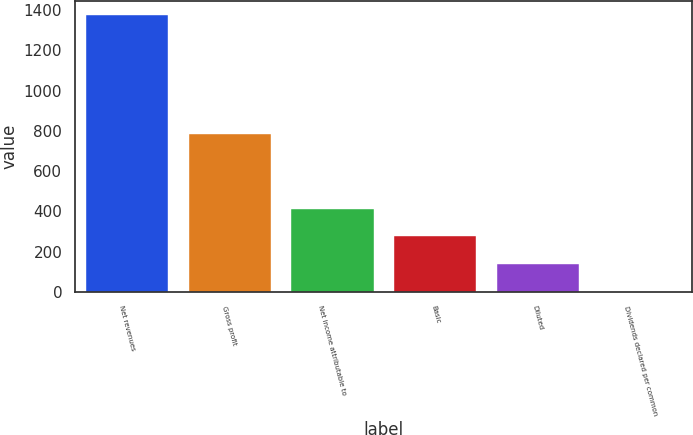Convert chart to OTSL. <chart><loc_0><loc_0><loc_500><loc_500><bar_chart><fcel>Net revenues<fcel>Gross profit<fcel>Net income attributable to<fcel>Basic<fcel>Diluted<fcel>Dividends declared per common<nl><fcel>1374.2<fcel>784.8<fcel>412.3<fcel>274.88<fcel>137.47<fcel>0.05<nl></chart> 